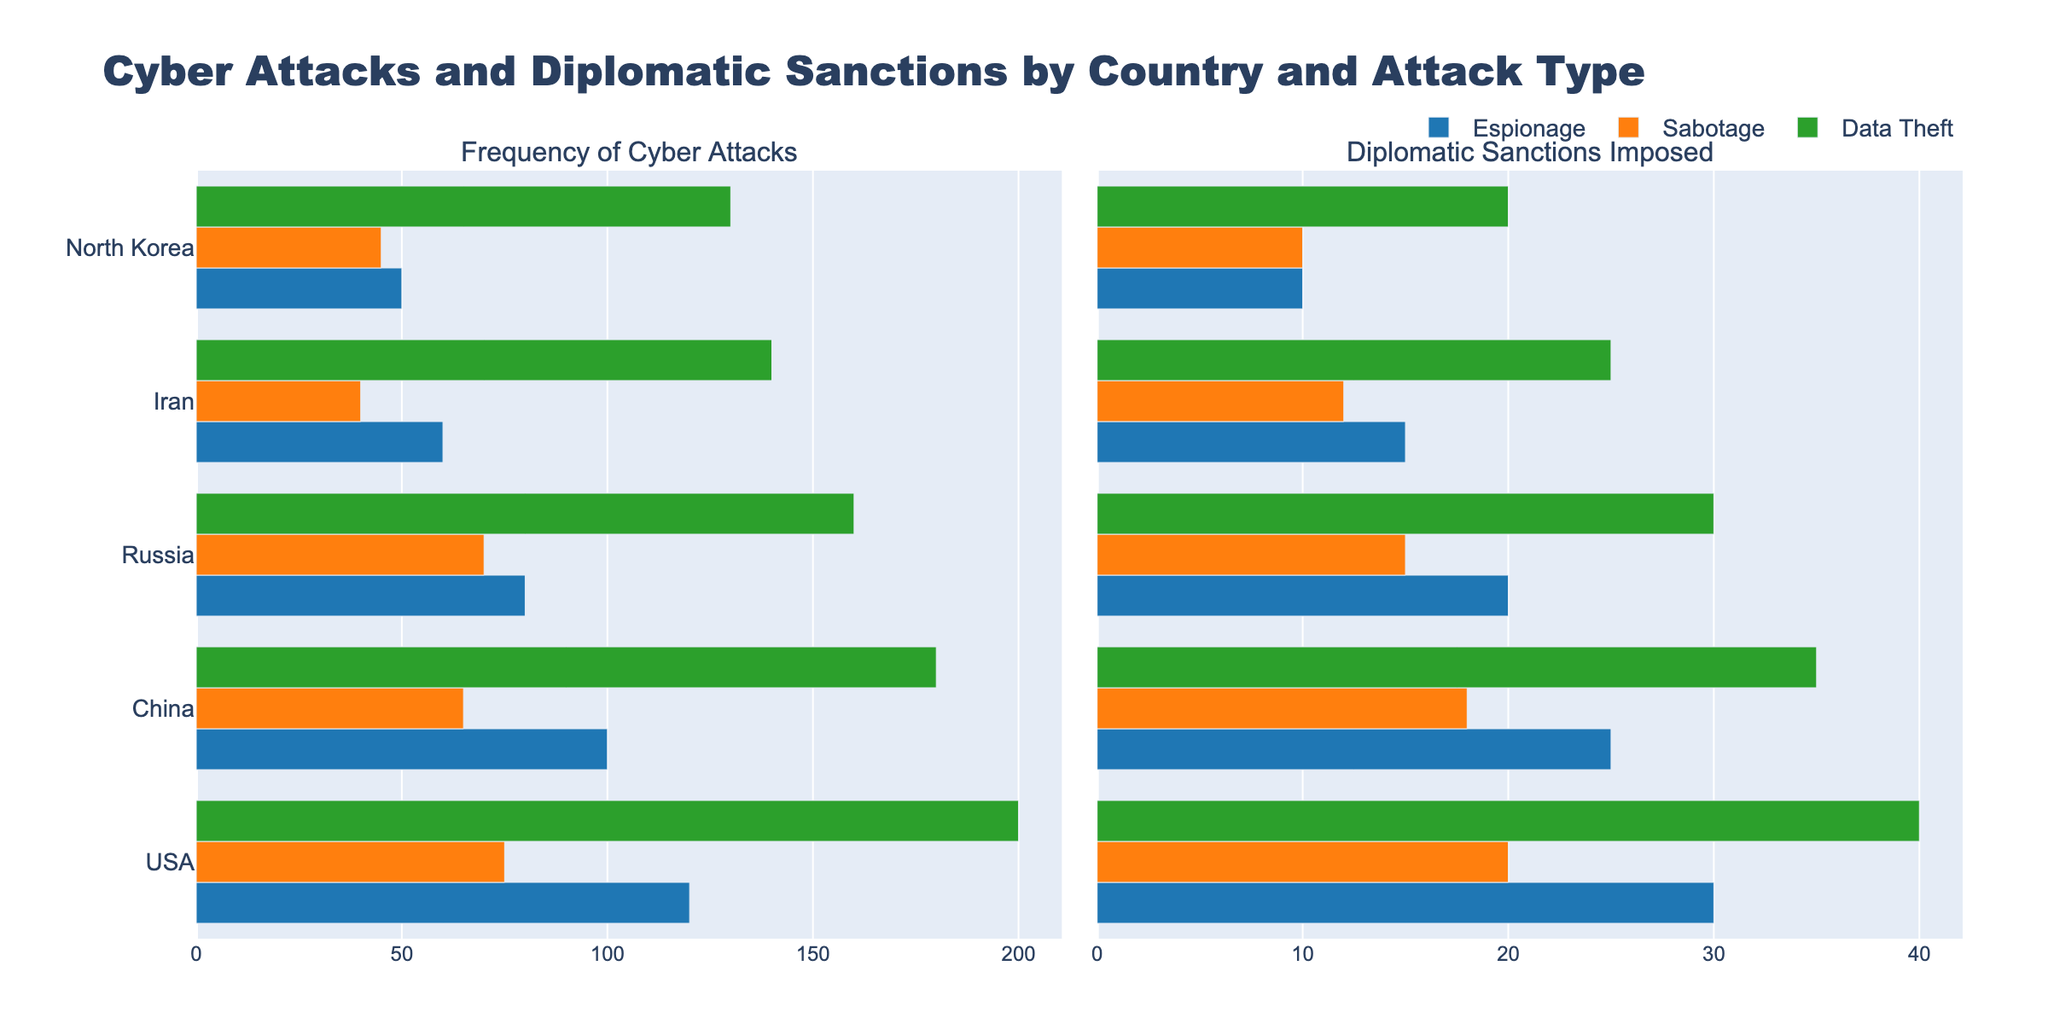Which country has the highest frequency of data theft? Identify the bars in the "Frequency of Cyber Attacks" subplot corresponding to "Data Theft" and compare their lengths. The longest bar corresponds to the USA.
Answer: USA What is the total diplomatic sanctions imposed due to sabotage by China and Russia? Locate the bars for "Sabotage - China" and "Sabotage - Russia" in the "Diplomatic Sanctions Imposed" subplot. Summing their heights gives 65 + 70 = 135.
Answer: 135 How does the frequency of espionage attacks by the USA compare to data theft by North Korea? Look for the lengths of the bars corresponding to "Espionage - USA" and "Data Theft - North Korea" in the "Frequency of Cyber Attacks" subplot. The bar for espionage by the USA is longer than the bar for data theft by North Korea (120 vs. 130).
Answer: Data Theft - North Korea is greater Which attack type results in the most sanctions for Iran? In the "Diplomatic Sanctions Imposed" subplot, identify the bars corresponding to Iran and compare their lengths. The longest bar pertains to Data Theft with a height of 25.
Answer: Data Theft What is the average frequency of sabotage attacks across all five countries? Add the frequencies of sabotage for all countries (75 + 65 + 70 + 40 + 45) to get 295. Then, divide by the number of countries (5): 295 / 5 = 59.
Answer: 59 How many more diplomatic sanctions have been imposed for data theft by China compared to North Korea? Identify the bars for "Data Theft - China" and "Data Theft - North Korea" in the "Diplomatic Sanctions Imposed" subplot. The difference in their lengths is 35 - 20 = 15.
Answer: 15 Which country has the least frequency of sabotage attacks? Compare the lengths of the bars in the "Frequency of Cyber Attacks" subplot for "Sabotage". The shortest bar is for Iran with a height of 40.
Answer: Iran If the bar for diplomatic sanctions imposed due to espionage in the USA is half as long, how many sanctions would that represent? The current length of the bar for "Espionage - USA" in "Diplomatic Sanctions Imposed" is 30. Half of this length would represent 30 / 2 = 15 sanctions.
Answer: 15 